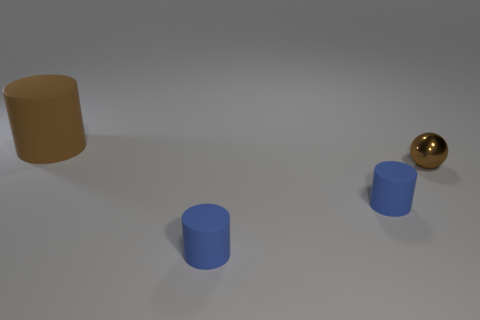Add 4 blue things. How many objects exist? 8 Subtract all balls. How many objects are left? 3 Subtract 0 blue blocks. How many objects are left? 4 Subtract all small cylinders. Subtract all big brown rubber cylinders. How many objects are left? 1 Add 3 tiny matte objects. How many tiny matte objects are left? 5 Add 3 small rubber cylinders. How many small rubber cylinders exist? 5 